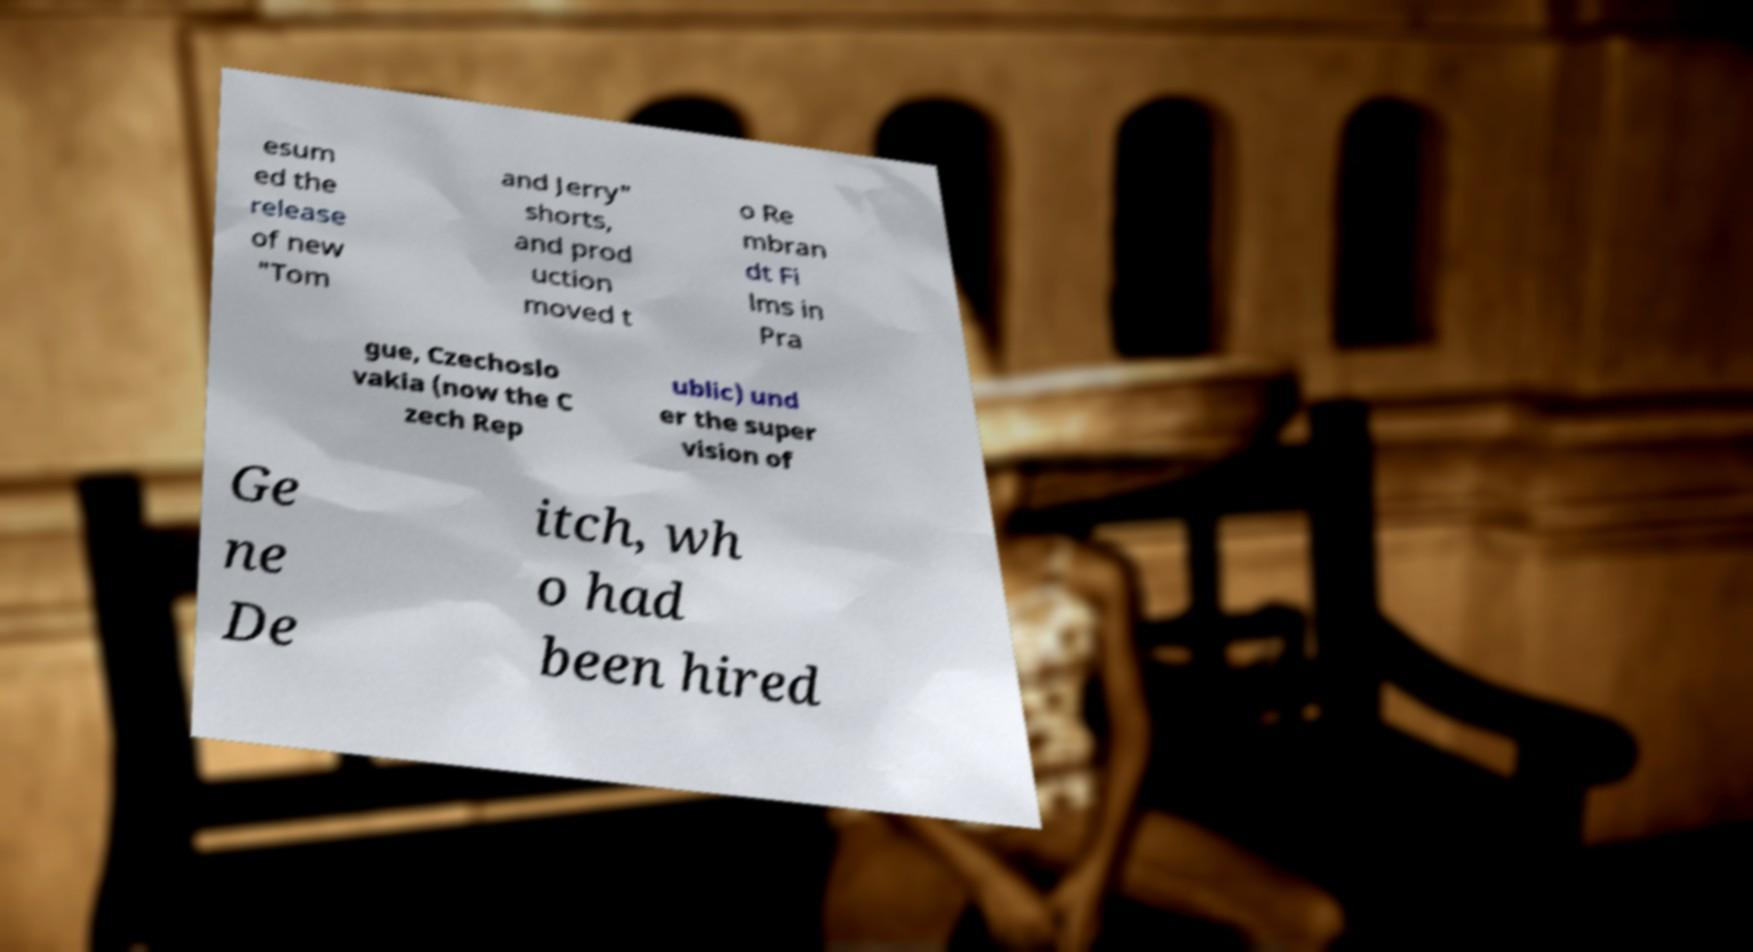I need the written content from this picture converted into text. Can you do that? esum ed the release of new "Tom and Jerry" shorts, and prod uction moved t o Re mbran dt Fi lms in Pra gue, Czechoslo vakia (now the C zech Rep ublic) und er the super vision of Ge ne De itch, wh o had been hired 